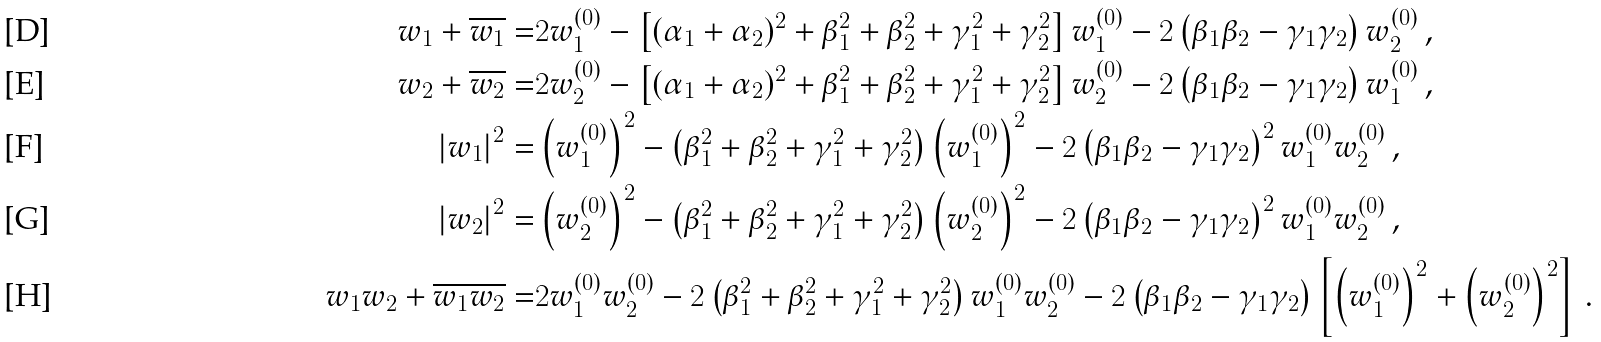Convert formula to latex. <formula><loc_0><loc_0><loc_500><loc_500>w _ { 1 } + \overline { w _ { 1 } } = & 2 w _ { 1 } ^ { ( 0 ) } - \left [ ( \alpha _ { 1 } + \alpha _ { 2 } ) ^ { 2 } + \beta _ { 1 } ^ { 2 } + \beta _ { 2 } ^ { 2 } + \gamma _ { 1 } ^ { 2 } + \gamma _ { 2 } ^ { 2 } \right ] w _ { 1 } ^ { ( 0 ) } - 2 \left ( \beta _ { 1 } \beta _ { 2 } - \gamma _ { 1 } \gamma _ { 2 } \right ) w _ { 2 } ^ { ( 0 ) } \, , \\ w _ { 2 } + \overline { w _ { 2 } } = & 2 w _ { 2 } ^ { ( 0 ) } - \left [ ( \alpha _ { 1 } + \alpha _ { 2 } ) ^ { 2 } + \beta _ { 1 } ^ { 2 } + \beta _ { 2 } ^ { 2 } + \gamma _ { 1 } ^ { 2 } + \gamma _ { 2 } ^ { 2 } \right ] w _ { 2 } ^ { ( 0 ) } - 2 \left ( \beta _ { 1 } \beta _ { 2 } - \gamma _ { 1 } \gamma _ { 2 } \right ) w _ { 1 } ^ { ( 0 ) } \, , \\ \left | w _ { 1 } \right | ^ { 2 } = & \left ( w _ { 1 } ^ { ( 0 ) } \right ) ^ { 2 } - \left ( \beta _ { 1 } ^ { 2 } + \beta _ { 2 } ^ { 2 } + \gamma _ { 1 } ^ { 2 } + \gamma _ { 2 } ^ { 2 } \right ) \left ( w _ { 1 } ^ { ( 0 ) } \right ) ^ { 2 } - 2 \left ( \beta _ { 1 } \beta _ { 2 } - \gamma _ { 1 } \gamma _ { 2 } \right ) ^ { 2 } w _ { 1 } ^ { ( 0 ) } w _ { 2 } ^ { ( 0 ) } \, , \\ \left | w _ { 2 } \right | ^ { 2 } = & \left ( w _ { 2 } ^ { ( 0 ) } \right ) ^ { 2 } - \left ( \beta _ { 1 } ^ { 2 } + \beta _ { 2 } ^ { 2 } + \gamma _ { 1 } ^ { 2 } + \gamma _ { 2 } ^ { 2 } \right ) \left ( w _ { 2 } ^ { ( 0 ) } \right ) ^ { 2 } - 2 \left ( \beta _ { 1 } \beta _ { 2 } - \gamma _ { 1 } \gamma _ { 2 } \right ) ^ { 2 } w _ { 1 } ^ { ( 0 ) } w _ { 2 } ^ { ( 0 ) } \, , \\ w _ { 1 } w _ { 2 } + \overline { w _ { 1 } } \overline { w _ { 2 } } = & 2 w _ { 1 } ^ { ( 0 ) } w _ { 2 } ^ { ( 0 ) } - 2 \left ( \beta _ { 1 } ^ { 2 } + \beta _ { 2 } ^ { 2 } + \gamma _ { 1 } ^ { 2 } + \gamma _ { 2 } ^ { 2 } \right ) w _ { 1 } ^ { ( 0 ) } w _ { 2 } ^ { ( 0 ) } - 2 \left ( \beta _ { 1 } \beta _ { 2 } - \gamma _ { 1 } \gamma _ { 2 } \right ) \left [ \left ( w _ { 1 } ^ { ( 0 ) } \right ) ^ { 2 } + \left ( w _ { 2 } ^ { ( 0 ) } \right ) ^ { 2 } \right ] \, .</formula> 